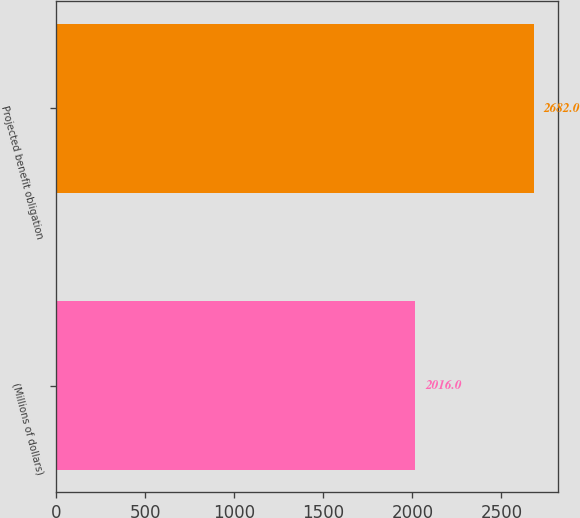<chart> <loc_0><loc_0><loc_500><loc_500><bar_chart><fcel>(Millions of dollars)<fcel>Projected benefit obligation<nl><fcel>2016<fcel>2682<nl></chart> 